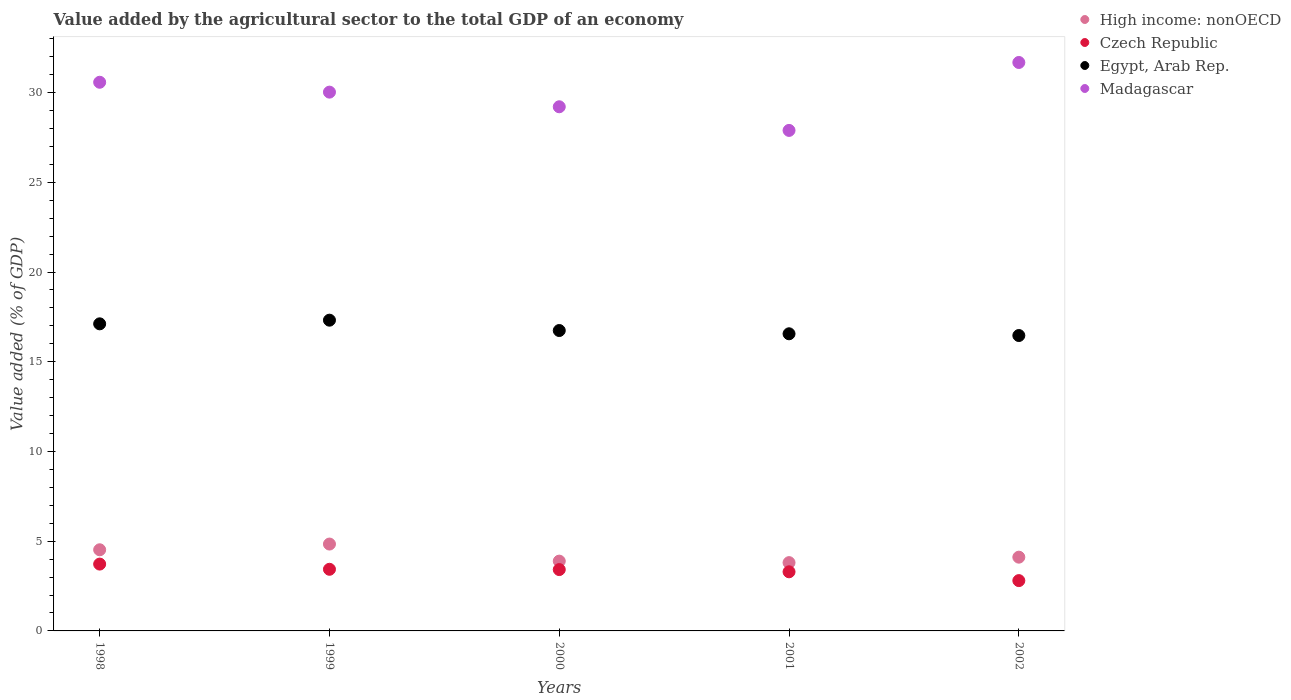What is the value added by the agricultural sector to the total GDP in High income: nonOECD in 2001?
Your answer should be compact. 3.81. Across all years, what is the maximum value added by the agricultural sector to the total GDP in Czech Republic?
Ensure brevity in your answer.  3.72. Across all years, what is the minimum value added by the agricultural sector to the total GDP in High income: nonOECD?
Ensure brevity in your answer.  3.81. In which year was the value added by the agricultural sector to the total GDP in High income: nonOECD maximum?
Keep it short and to the point. 1999. What is the total value added by the agricultural sector to the total GDP in Madagascar in the graph?
Make the answer very short. 149.38. What is the difference between the value added by the agricultural sector to the total GDP in High income: nonOECD in 1998 and that in 2002?
Your answer should be very brief. 0.41. What is the difference between the value added by the agricultural sector to the total GDP in Czech Republic in 2002 and the value added by the agricultural sector to the total GDP in High income: nonOECD in 2001?
Provide a succinct answer. -1. What is the average value added by the agricultural sector to the total GDP in High income: nonOECD per year?
Your response must be concise. 4.23. In the year 2002, what is the difference between the value added by the agricultural sector to the total GDP in Madagascar and value added by the agricultural sector to the total GDP in Egypt, Arab Rep.?
Ensure brevity in your answer.  15.22. What is the ratio of the value added by the agricultural sector to the total GDP in High income: nonOECD in 1999 to that in 2000?
Ensure brevity in your answer.  1.24. Is the value added by the agricultural sector to the total GDP in Czech Republic in 2001 less than that in 2002?
Ensure brevity in your answer.  No. Is the difference between the value added by the agricultural sector to the total GDP in Madagascar in 2000 and 2002 greater than the difference between the value added by the agricultural sector to the total GDP in Egypt, Arab Rep. in 2000 and 2002?
Give a very brief answer. No. What is the difference between the highest and the second highest value added by the agricultural sector to the total GDP in Egypt, Arab Rep.?
Your answer should be compact. 0.2. What is the difference between the highest and the lowest value added by the agricultural sector to the total GDP in Egypt, Arab Rep.?
Give a very brief answer. 0.86. Is the sum of the value added by the agricultural sector to the total GDP in High income: nonOECD in 1998 and 2000 greater than the maximum value added by the agricultural sector to the total GDP in Czech Republic across all years?
Ensure brevity in your answer.  Yes. Is it the case that in every year, the sum of the value added by the agricultural sector to the total GDP in Madagascar and value added by the agricultural sector to the total GDP in High income: nonOECD  is greater than the sum of value added by the agricultural sector to the total GDP in Czech Republic and value added by the agricultural sector to the total GDP in Egypt, Arab Rep.?
Your answer should be compact. No. Is it the case that in every year, the sum of the value added by the agricultural sector to the total GDP in Egypt, Arab Rep. and value added by the agricultural sector to the total GDP in Czech Republic  is greater than the value added by the agricultural sector to the total GDP in Madagascar?
Offer a terse response. No. Is the value added by the agricultural sector to the total GDP in High income: nonOECD strictly greater than the value added by the agricultural sector to the total GDP in Egypt, Arab Rep. over the years?
Your answer should be very brief. No. How many dotlines are there?
Offer a very short reply. 4. How many years are there in the graph?
Provide a succinct answer. 5. Are the values on the major ticks of Y-axis written in scientific E-notation?
Ensure brevity in your answer.  No. Does the graph contain any zero values?
Your answer should be very brief. No. Does the graph contain grids?
Give a very brief answer. No. How are the legend labels stacked?
Offer a terse response. Vertical. What is the title of the graph?
Your answer should be compact. Value added by the agricultural sector to the total GDP of an economy. Does "Jordan" appear as one of the legend labels in the graph?
Give a very brief answer. No. What is the label or title of the Y-axis?
Keep it short and to the point. Value added (% of GDP). What is the Value added (% of GDP) in High income: nonOECD in 1998?
Give a very brief answer. 4.52. What is the Value added (% of GDP) in Czech Republic in 1998?
Provide a short and direct response. 3.72. What is the Value added (% of GDP) of Egypt, Arab Rep. in 1998?
Your answer should be compact. 17.11. What is the Value added (% of GDP) of Madagascar in 1998?
Ensure brevity in your answer.  30.58. What is the Value added (% of GDP) of High income: nonOECD in 1999?
Ensure brevity in your answer.  4.84. What is the Value added (% of GDP) in Czech Republic in 1999?
Make the answer very short. 3.43. What is the Value added (% of GDP) of Egypt, Arab Rep. in 1999?
Provide a short and direct response. 17.32. What is the Value added (% of GDP) of Madagascar in 1999?
Your answer should be compact. 30.03. What is the Value added (% of GDP) in High income: nonOECD in 2000?
Your answer should be very brief. 3.89. What is the Value added (% of GDP) in Czech Republic in 2000?
Your answer should be very brief. 3.42. What is the Value added (% of GDP) of Egypt, Arab Rep. in 2000?
Provide a succinct answer. 16.74. What is the Value added (% of GDP) of Madagascar in 2000?
Keep it short and to the point. 29.21. What is the Value added (% of GDP) of High income: nonOECD in 2001?
Offer a very short reply. 3.81. What is the Value added (% of GDP) in Czech Republic in 2001?
Make the answer very short. 3.29. What is the Value added (% of GDP) of Egypt, Arab Rep. in 2001?
Your answer should be very brief. 16.56. What is the Value added (% of GDP) of Madagascar in 2001?
Make the answer very short. 27.89. What is the Value added (% of GDP) of High income: nonOECD in 2002?
Provide a succinct answer. 4.11. What is the Value added (% of GDP) of Czech Republic in 2002?
Give a very brief answer. 2.8. What is the Value added (% of GDP) in Egypt, Arab Rep. in 2002?
Your response must be concise. 16.46. What is the Value added (% of GDP) of Madagascar in 2002?
Your answer should be very brief. 31.68. Across all years, what is the maximum Value added (% of GDP) of High income: nonOECD?
Provide a short and direct response. 4.84. Across all years, what is the maximum Value added (% of GDP) of Czech Republic?
Give a very brief answer. 3.72. Across all years, what is the maximum Value added (% of GDP) in Egypt, Arab Rep.?
Give a very brief answer. 17.32. Across all years, what is the maximum Value added (% of GDP) of Madagascar?
Provide a succinct answer. 31.68. Across all years, what is the minimum Value added (% of GDP) of High income: nonOECD?
Your answer should be very brief. 3.81. Across all years, what is the minimum Value added (% of GDP) in Czech Republic?
Your response must be concise. 2.8. Across all years, what is the minimum Value added (% of GDP) of Egypt, Arab Rep.?
Make the answer very short. 16.46. Across all years, what is the minimum Value added (% of GDP) of Madagascar?
Your answer should be compact. 27.89. What is the total Value added (% of GDP) of High income: nonOECD in the graph?
Your answer should be compact. 21.17. What is the total Value added (% of GDP) of Czech Republic in the graph?
Ensure brevity in your answer.  16.68. What is the total Value added (% of GDP) in Egypt, Arab Rep. in the graph?
Provide a short and direct response. 84.19. What is the total Value added (% of GDP) in Madagascar in the graph?
Give a very brief answer. 149.38. What is the difference between the Value added (% of GDP) in High income: nonOECD in 1998 and that in 1999?
Your response must be concise. -0.32. What is the difference between the Value added (% of GDP) of Czech Republic in 1998 and that in 1999?
Keep it short and to the point. 0.29. What is the difference between the Value added (% of GDP) in Egypt, Arab Rep. in 1998 and that in 1999?
Offer a terse response. -0.2. What is the difference between the Value added (% of GDP) in Madagascar in 1998 and that in 1999?
Your answer should be very brief. 0.55. What is the difference between the Value added (% of GDP) of High income: nonOECD in 1998 and that in 2000?
Ensure brevity in your answer.  0.63. What is the difference between the Value added (% of GDP) of Czech Republic in 1998 and that in 2000?
Keep it short and to the point. 0.31. What is the difference between the Value added (% of GDP) in Egypt, Arab Rep. in 1998 and that in 2000?
Keep it short and to the point. 0.37. What is the difference between the Value added (% of GDP) of Madagascar in 1998 and that in 2000?
Offer a terse response. 1.37. What is the difference between the Value added (% of GDP) in High income: nonOECD in 1998 and that in 2001?
Your response must be concise. 0.72. What is the difference between the Value added (% of GDP) of Czech Republic in 1998 and that in 2001?
Keep it short and to the point. 0.43. What is the difference between the Value added (% of GDP) of Egypt, Arab Rep. in 1998 and that in 2001?
Offer a terse response. 0.56. What is the difference between the Value added (% of GDP) of Madagascar in 1998 and that in 2001?
Provide a succinct answer. 2.68. What is the difference between the Value added (% of GDP) of High income: nonOECD in 1998 and that in 2002?
Your response must be concise. 0.41. What is the difference between the Value added (% of GDP) of Czech Republic in 1998 and that in 2002?
Offer a very short reply. 0.92. What is the difference between the Value added (% of GDP) in Egypt, Arab Rep. in 1998 and that in 2002?
Give a very brief answer. 0.65. What is the difference between the Value added (% of GDP) of Madagascar in 1998 and that in 2002?
Make the answer very short. -1.1. What is the difference between the Value added (% of GDP) in High income: nonOECD in 1999 and that in 2000?
Offer a very short reply. 0.95. What is the difference between the Value added (% of GDP) in Czech Republic in 1999 and that in 2000?
Ensure brevity in your answer.  0.02. What is the difference between the Value added (% of GDP) in Egypt, Arab Rep. in 1999 and that in 2000?
Provide a short and direct response. 0.58. What is the difference between the Value added (% of GDP) of Madagascar in 1999 and that in 2000?
Keep it short and to the point. 0.82. What is the difference between the Value added (% of GDP) of High income: nonOECD in 1999 and that in 2001?
Offer a terse response. 1.04. What is the difference between the Value added (% of GDP) of Czech Republic in 1999 and that in 2001?
Your answer should be very brief. 0.14. What is the difference between the Value added (% of GDP) in Egypt, Arab Rep. in 1999 and that in 2001?
Keep it short and to the point. 0.76. What is the difference between the Value added (% of GDP) of Madagascar in 1999 and that in 2001?
Offer a terse response. 2.13. What is the difference between the Value added (% of GDP) of High income: nonOECD in 1999 and that in 2002?
Offer a terse response. 0.73. What is the difference between the Value added (% of GDP) of Czech Republic in 1999 and that in 2002?
Offer a terse response. 0.63. What is the difference between the Value added (% of GDP) of Egypt, Arab Rep. in 1999 and that in 2002?
Ensure brevity in your answer.  0.86. What is the difference between the Value added (% of GDP) of Madagascar in 1999 and that in 2002?
Give a very brief answer. -1.65. What is the difference between the Value added (% of GDP) in High income: nonOECD in 2000 and that in 2001?
Ensure brevity in your answer.  0.08. What is the difference between the Value added (% of GDP) of Czech Republic in 2000 and that in 2001?
Your response must be concise. 0.12. What is the difference between the Value added (% of GDP) in Egypt, Arab Rep. in 2000 and that in 2001?
Keep it short and to the point. 0.18. What is the difference between the Value added (% of GDP) in Madagascar in 2000 and that in 2001?
Give a very brief answer. 1.32. What is the difference between the Value added (% of GDP) in High income: nonOECD in 2000 and that in 2002?
Your answer should be compact. -0.22. What is the difference between the Value added (% of GDP) of Czech Republic in 2000 and that in 2002?
Give a very brief answer. 0.61. What is the difference between the Value added (% of GDP) of Egypt, Arab Rep. in 2000 and that in 2002?
Provide a short and direct response. 0.28. What is the difference between the Value added (% of GDP) in Madagascar in 2000 and that in 2002?
Make the answer very short. -2.47. What is the difference between the Value added (% of GDP) of High income: nonOECD in 2001 and that in 2002?
Provide a succinct answer. -0.3. What is the difference between the Value added (% of GDP) in Czech Republic in 2001 and that in 2002?
Offer a terse response. 0.49. What is the difference between the Value added (% of GDP) in Egypt, Arab Rep. in 2001 and that in 2002?
Offer a terse response. 0.1. What is the difference between the Value added (% of GDP) of Madagascar in 2001 and that in 2002?
Provide a short and direct response. -3.79. What is the difference between the Value added (% of GDP) in High income: nonOECD in 1998 and the Value added (% of GDP) in Czech Republic in 1999?
Your answer should be very brief. 1.09. What is the difference between the Value added (% of GDP) in High income: nonOECD in 1998 and the Value added (% of GDP) in Egypt, Arab Rep. in 1999?
Provide a succinct answer. -12.8. What is the difference between the Value added (% of GDP) in High income: nonOECD in 1998 and the Value added (% of GDP) in Madagascar in 1999?
Keep it short and to the point. -25.5. What is the difference between the Value added (% of GDP) of Czech Republic in 1998 and the Value added (% of GDP) of Egypt, Arab Rep. in 1999?
Your answer should be compact. -13.59. What is the difference between the Value added (% of GDP) in Czech Republic in 1998 and the Value added (% of GDP) in Madagascar in 1999?
Your answer should be compact. -26.3. What is the difference between the Value added (% of GDP) in Egypt, Arab Rep. in 1998 and the Value added (% of GDP) in Madagascar in 1999?
Make the answer very short. -12.91. What is the difference between the Value added (% of GDP) in High income: nonOECD in 1998 and the Value added (% of GDP) in Czech Republic in 2000?
Ensure brevity in your answer.  1.1. What is the difference between the Value added (% of GDP) of High income: nonOECD in 1998 and the Value added (% of GDP) of Egypt, Arab Rep. in 2000?
Ensure brevity in your answer.  -12.22. What is the difference between the Value added (% of GDP) of High income: nonOECD in 1998 and the Value added (% of GDP) of Madagascar in 2000?
Your response must be concise. -24.69. What is the difference between the Value added (% of GDP) of Czech Republic in 1998 and the Value added (% of GDP) of Egypt, Arab Rep. in 2000?
Your answer should be very brief. -13.02. What is the difference between the Value added (% of GDP) of Czech Republic in 1998 and the Value added (% of GDP) of Madagascar in 2000?
Offer a very short reply. -25.49. What is the difference between the Value added (% of GDP) in Egypt, Arab Rep. in 1998 and the Value added (% of GDP) in Madagascar in 2000?
Give a very brief answer. -12.1. What is the difference between the Value added (% of GDP) in High income: nonOECD in 1998 and the Value added (% of GDP) in Czech Republic in 2001?
Provide a succinct answer. 1.23. What is the difference between the Value added (% of GDP) of High income: nonOECD in 1998 and the Value added (% of GDP) of Egypt, Arab Rep. in 2001?
Your answer should be very brief. -12.04. What is the difference between the Value added (% of GDP) in High income: nonOECD in 1998 and the Value added (% of GDP) in Madagascar in 2001?
Provide a succinct answer. -23.37. What is the difference between the Value added (% of GDP) in Czech Republic in 1998 and the Value added (% of GDP) in Egypt, Arab Rep. in 2001?
Keep it short and to the point. -12.83. What is the difference between the Value added (% of GDP) of Czech Republic in 1998 and the Value added (% of GDP) of Madagascar in 2001?
Give a very brief answer. -24.17. What is the difference between the Value added (% of GDP) in Egypt, Arab Rep. in 1998 and the Value added (% of GDP) in Madagascar in 2001?
Your answer should be compact. -10.78. What is the difference between the Value added (% of GDP) in High income: nonOECD in 1998 and the Value added (% of GDP) in Czech Republic in 2002?
Ensure brevity in your answer.  1.72. What is the difference between the Value added (% of GDP) in High income: nonOECD in 1998 and the Value added (% of GDP) in Egypt, Arab Rep. in 2002?
Provide a short and direct response. -11.94. What is the difference between the Value added (% of GDP) of High income: nonOECD in 1998 and the Value added (% of GDP) of Madagascar in 2002?
Give a very brief answer. -27.16. What is the difference between the Value added (% of GDP) in Czech Republic in 1998 and the Value added (% of GDP) in Egypt, Arab Rep. in 2002?
Keep it short and to the point. -12.74. What is the difference between the Value added (% of GDP) in Czech Republic in 1998 and the Value added (% of GDP) in Madagascar in 2002?
Provide a succinct answer. -27.95. What is the difference between the Value added (% of GDP) of Egypt, Arab Rep. in 1998 and the Value added (% of GDP) of Madagascar in 2002?
Offer a terse response. -14.56. What is the difference between the Value added (% of GDP) in High income: nonOECD in 1999 and the Value added (% of GDP) in Czech Republic in 2000?
Ensure brevity in your answer.  1.42. What is the difference between the Value added (% of GDP) in High income: nonOECD in 1999 and the Value added (% of GDP) in Egypt, Arab Rep. in 2000?
Keep it short and to the point. -11.9. What is the difference between the Value added (% of GDP) in High income: nonOECD in 1999 and the Value added (% of GDP) in Madagascar in 2000?
Offer a very short reply. -24.37. What is the difference between the Value added (% of GDP) of Czech Republic in 1999 and the Value added (% of GDP) of Egypt, Arab Rep. in 2000?
Make the answer very short. -13.31. What is the difference between the Value added (% of GDP) in Czech Republic in 1999 and the Value added (% of GDP) in Madagascar in 2000?
Give a very brief answer. -25.78. What is the difference between the Value added (% of GDP) in Egypt, Arab Rep. in 1999 and the Value added (% of GDP) in Madagascar in 2000?
Make the answer very short. -11.89. What is the difference between the Value added (% of GDP) of High income: nonOECD in 1999 and the Value added (% of GDP) of Czech Republic in 2001?
Offer a very short reply. 1.55. What is the difference between the Value added (% of GDP) in High income: nonOECD in 1999 and the Value added (% of GDP) in Egypt, Arab Rep. in 2001?
Give a very brief answer. -11.72. What is the difference between the Value added (% of GDP) of High income: nonOECD in 1999 and the Value added (% of GDP) of Madagascar in 2001?
Give a very brief answer. -23.05. What is the difference between the Value added (% of GDP) in Czech Republic in 1999 and the Value added (% of GDP) in Egypt, Arab Rep. in 2001?
Your response must be concise. -13.12. What is the difference between the Value added (% of GDP) in Czech Republic in 1999 and the Value added (% of GDP) in Madagascar in 2001?
Ensure brevity in your answer.  -24.46. What is the difference between the Value added (% of GDP) of Egypt, Arab Rep. in 1999 and the Value added (% of GDP) of Madagascar in 2001?
Offer a very short reply. -10.58. What is the difference between the Value added (% of GDP) in High income: nonOECD in 1999 and the Value added (% of GDP) in Czech Republic in 2002?
Make the answer very short. 2.04. What is the difference between the Value added (% of GDP) of High income: nonOECD in 1999 and the Value added (% of GDP) of Egypt, Arab Rep. in 2002?
Your answer should be very brief. -11.62. What is the difference between the Value added (% of GDP) in High income: nonOECD in 1999 and the Value added (% of GDP) in Madagascar in 2002?
Give a very brief answer. -26.84. What is the difference between the Value added (% of GDP) of Czech Republic in 1999 and the Value added (% of GDP) of Egypt, Arab Rep. in 2002?
Keep it short and to the point. -13.03. What is the difference between the Value added (% of GDP) in Czech Republic in 1999 and the Value added (% of GDP) in Madagascar in 2002?
Your answer should be compact. -28.24. What is the difference between the Value added (% of GDP) of Egypt, Arab Rep. in 1999 and the Value added (% of GDP) of Madagascar in 2002?
Your answer should be very brief. -14.36. What is the difference between the Value added (% of GDP) in High income: nonOECD in 2000 and the Value added (% of GDP) in Czech Republic in 2001?
Give a very brief answer. 0.59. What is the difference between the Value added (% of GDP) in High income: nonOECD in 2000 and the Value added (% of GDP) in Egypt, Arab Rep. in 2001?
Ensure brevity in your answer.  -12.67. What is the difference between the Value added (% of GDP) in High income: nonOECD in 2000 and the Value added (% of GDP) in Madagascar in 2001?
Offer a very short reply. -24. What is the difference between the Value added (% of GDP) in Czech Republic in 2000 and the Value added (% of GDP) in Egypt, Arab Rep. in 2001?
Give a very brief answer. -13.14. What is the difference between the Value added (% of GDP) in Czech Republic in 2000 and the Value added (% of GDP) in Madagascar in 2001?
Ensure brevity in your answer.  -24.47. What is the difference between the Value added (% of GDP) in Egypt, Arab Rep. in 2000 and the Value added (% of GDP) in Madagascar in 2001?
Your response must be concise. -11.15. What is the difference between the Value added (% of GDP) of High income: nonOECD in 2000 and the Value added (% of GDP) of Czech Republic in 2002?
Ensure brevity in your answer.  1.09. What is the difference between the Value added (% of GDP) in High income: nonOECD in 2000 and the Value added (% of GDP) in Egypt, Arab Rep. in 2002?
Provide a short and direct response. -12.57. What is the difference between the Value added (% of GDP) of High income: nonOECD in 2000 and the Value added (% of GDP) of Madagascar in 2002?
Offer a terse response. -27.79. What is the difference between the Value added (% of GDP) of Czech Republic in 2000 and the Value added (% of GDP) of Egypt, Arab Rep. in 2002?
Your answer should be compact. -13.04. What is the difference between the Value added (% of GDP) of Czech Republic in 2000 and the Value added (% of GDP) of Madagascar in 2002?
Your answer should be very brief. -28.26. What is the difference between the Value added (% of GDP) in Egypt, Arab Rep. in 2000 and the Value added (% of GDP) in Madagascar in 2002?
Offer a terse response. -14.94. What is the difference between the Value added (% of GDP) in High income: nonOECD in 2001 and the Value added (% of GDP) in Egypt, Arab Rep. in 2002?
Keep it short and to the point. -12.66. What is the difference between the Value added (% of GDP) in High income: nonOECD in 2001 and the Value added (% of GDP) in Madagascar in 2002?
Offer a terse response. -27.87. What is the difference between the Value added (% of GDP) of Czech Republic in 2001 and the Value added (% of GDP) of Egypt, Arab Rep. in 2002?
Offer a terse response. -13.17. What is the difference between the Value added (% of GDP) of Czech Republic in 2001 and the Value added (% of GDP) of Madagascar in 2002?
Ensure brevity in your answer.  -28.38. What is the difference between the Value added (% of GDP) of Egypt, Arab Rep. in 2001 and the Value added (% of GDP) of Madagascar in 2002?
Give a very brief answer. -15.12. What is the average Value added (% of GDP) in High income: nonOECD per year?
Your answer should be compact. 4.23. What is the average Value added (% of GDP) of Czech Republic per year?
Offer a very short reply. 3.34. What is the average Value added (% of GDP) of Egypt, Arab Rep. per year?
Offer a terse response. 16.84. What is the average Value added (% of GDP) of Madagascar per year?
Ensure brevity in your answer.  29.88. In the year 1998, what is the difference between the Value added (% of GDP) in High income: nonOECD and Value added (% of GDP) in Czech Republic?
Keep it short and to the point. 0.8. In the year 1998, what is the difference between the Value added (% of GDP) in High income: nonOECD and Value added (% of GDP) in Egypt, Arab Rep.?
Offer a very short reply. -12.59. In the year 1998, what is the difference between the Value added (% of GDP) in High income: nonOECD and Value added (% of GDP) in Madagascar?
Offer a very short reply. -26.05. In the year 1998, what is the difference between the Value added (% of GDP) in Czech Republic and Value added (% of GDP) in Egypt, Arab Rep.?
Your answer should be very brief. -13.39. In the year 1998, what is the difference between the Value added (% of GDP) of Czech Republic and Value added (% of GDP) of Madagascar?
Your answer should be compact. -26.85. In the year 1998, what is the difference between the Value added (% of GDP) in Egypt, Arab Rep. and Value added (% of GDP) in Madagascar?
Ensure brevity in your answer.  -13.46. In the year 1999, what is the difference between the Value added (% of GDP) of High income: nonOECD and Value added (% of GDP) of Czech Republic?
Offer a very short reply. 1.41. In the year 1999, what is the difference between the Value added (% of GDP) in High income: nonOECD and Value added (% of GDP) in Egypt, Arab Rep.?
Your answer should be very brief. -12.48. In the year 1999, what is the difference between the Value added (% of GDP) of High income: nonOECD and Value added (% of GDP) of Madagascar?
Offer a very short reply. -25.18. In the year 1999, what is the difference between the Value added (% of GDP) in Czech Republic and Value added (% of GDP) in Egypt, Arab Rep.?
Make the answer very short. -13.88. In the year 1999, what is the difference between the Value added (% of GDP) of Czech Republic and Value added (% of GDP) of Madagascar?
Give a very brief answer. -26.59. In the year 1999, what is the difference between the Value added (% of GDP) of Egypt, Arab Rep. and Value added (% of GDP) of Madagascar?
Offer a terse response. -12.71. In the year 2000, what is the difference between the Value added (% of GDP) in High income: nonOECD and Value added (% of GDP) in Czech Republic?
Give a very brief answer. 0.47. In the year 2000, what is the difference between the Value added (% of GDP) of High income: nonOECD and Value added (% of GDP) of Egypt, Arab Rep.?
Keep it short and to the point. -12.85. In the year 2000, what is the difference between the Value added (% of GDP) in High income: nonOECD and Value added (% of GDP) in Madagascar?
Your answer should be compact. -25.32. In the year 2000, what is the difference between the Value added (% of GDP) of Czech Republic and Value added (% of GDP) of Egypt, Arab Rep.?
Ensure brevity in your answer.  -13.32. In the year 2000, what is the difference between the Value added (% of GDP) of Czech Republic and Value added (% of GDP) of Madagascar?
Your response must be concise. -25.79. In the year 2000, what is the difference between the Value added (% of GDP) of Egypt, Arab Rep. and Value added (% of GDP) of Madagascar?
Provide a short and direct response. -12.47. In the year 2001, what is the difference between the Value added (% of GDP) in High income: nonOECD and Value added (% of GDP) in Czech Republic?
Provide a succinct answer. 0.51. In the year 2001, what is the difference between the Value added (% of GDP) of High income: nonOECD and Value added (% of GDP) of Egypt, Arab Rep.?
Provide a short and direct response. -12.75. In the year 2001, what is the difference between the Value added (% of GDP) in High income: nonOECD and Value added (% of GDP) in Madagascar?
Provide a short and direct response. -24.09. In the year 2001, what is the difference between the Value added (% of GDP) of Czech Republic and Value added (% of GDP) of Egypt, Arab Rep.?
Make the answer very short. -13.26. In the year 2001, what is the difference between the Value added (% of GDP) in Czech Republic and Value added (% of GDP) in Madagascar?
Keep it short and to the point. -24.6. In the year 2001, what is the difference between the Value added (% of GDP) in Egypt, Arab Rep. and Value added (% of GDP) in Madagascar?
Your answer should be very brief. -11.33. In the year 2002, what is the difference between the Value added (% of GDP) in High income: nonOECD and Value added (% of GDP) in Czech Republic?
Offer a very short reply. 1.31. In the year 2002, what is the difference between the Value added (% of GDP) of High income: nonOECD and Value added (% of GDP) of Egypt, Arab Rep.?
Your answer should be very brief. -12.35. In the year 2002, what is the difference between the Value added (% of GDP) in High income: nonOECD and Value added (% of GDP) in Madagascar?
Offer a terse response. -27.57. In the year 2002, what is the difference between the Value added (% of GDP) in Czech Republic and Value added (% of GDP) in Egypt, Arab Rep.?
Make the answer very short. -13.66. In the year 2002, what is the difference between the Value added (% of GDP) of Czech Republic and Value added (% of GDP) of Madagascar?
Make the answer very short. -28.87. In the year 2002, what is the difference between the Value added (% of GDP) in Egypt, Arab Rep. and Value added (% of GDP) in Madagascar?
Make the answer very short. -15.22. What is the ratio of the Value added (% of GDP) in High income: nonOECD in 1998 to that in 1999?
Your answer should be compact. 0.93. What is the ratio of the Value added (% of GDP) in Czech Republic in 1998 to that in 1999?
Give a very brief answer. 1.08. What is the ratio of the Value added (% of GDP) of Egypt, Arab Rep. in 1998 to that in 1999?
Ensure brevity in your answer.  0.99. What is the ratio of the Value added (% of GDP) in Madagascar in 1998 to that in 1999?
Ensure brevity in your answer.  1.02. What is the ratio of the Value added (% of GDP) in High income: nonOECD in 1998 to that in 2000?
Provide a short and direct response. 1.16. What is the ratio of the Value added (% of GDP) of Czech Republic in 1998 to that in 2000?
Your answer should be very brief. 1.09. What is the ratio of the Value added (% of GDP) of Egypt, Arab Rep. in 1998 to that in 2000?
Your answer should be compact. 1.02. What is the ratio of the Value added (% of GDP) of Madagascar in 1998 to that in 2000?
Make the answer very short. 1.05. What is the ratio of the Value added (% of GDP) in High income: nonOECD in 1998 to that in 2001?
Keep it short and to the point. 1.19. What is the ratio of the Value added (% of GDP) of Czech Republic in 1998 to that in 2001?
Your response must be concise. 1.13. What is the ratio of the Value added (% of GDP) in Egypt, Arab Rep. in 1998 to that in 2001?
Provide a short and direct response. 1.03. What is the ratio of the Value added (% of GDP) in Madagascar in 1998 to that in 2001?
Offer a very short reply. 1.1. What is the ratio of the Value added (% of GDP) of High income: nonOECD in 1998 to that in 2002?
Provide a short and direct response. 1.1. What is the ratio of the Value added (% of GDP) in Czech Republic in 1998 to that in 2002?
Offer a terse response. 1.33. What is the ratio of the Value added (% of GDP) in Egypt, Arab Rep. in 1998 to that in 2002?
Keep it short and to the point. 1.04. What is the ratio of the Value added (% of GDP) of Madagascar in 1998 to that in 2002?
Offer a terse response. 0.97. What is the ratio of the Value added (% of GDP) of High income: nonOECD in 1999 to that in 2000?
Provide a succinct answer. 1.24. What is the ratio of the Value added (% of GDP) in Czech Republic in 1999 to that in 2000?
Ensure brevity in your answer.  1. What is the ratio of the Value added (% of GDP) in Egypt, Arab Rep. in 1999 to that in 2000?
Your answer should be compact. 1.03. What is the ratio of the Value added (% of GDP) in Madagascar in 1999 to that in 2000?
Offer a terse response. 1.03. What is the ratio of the Value added (% of GDP) of High income: nonOECD in 1999 to that in 2001?
Ensure brevity in your answer.  1.27. What is the ratio of the Value added (% of GDP) of Czech Republic in 1999 to that in 2001?
Offer a very short reply. 1.04. What is the ratio of the Value added (% of GDP) of Egypt, Arab Rep. in 1999 to that in 2001?
Your response must be concise. 1.05. What is the ratio of the Value added (% of GDP) in Madagascar in 1999 to that in 2001?
Offer a very short reply. 1.08. What is the ratio of the Value added (% of GDP) in High income: nonOECD in 1999 to that in 2002?
Keep it short and to the point. 1.18. What is the ratio of the Value added (% of GDP) in Czech Republic in 1999 to that in 2002?
Offer a terse response. 1.23. What is the ratio of the Value added (% of GDP) in Egypt, Arab Rep. in 1999 to that in 2002?
Offer a very short reply. 1.05. What is the ratio of the Value added (% of GDP) of Madagascar in 1999 to that in 2002?
Provide a short and direct response. 0.95. What is the ratio of the Value added (% of GDP) of High income: nonOECD in 2000 to that in 2001?
Provide a short and direct response. 1.02. What is the ratio of the Value added (% of GDP) in Czech Republic in 2000 to that in 2001?
Your response must be concise. 1.04. What is the ratio of the Value added (% of GDP) of Madagascar in 2000 to that in 2001?
Your response must be concise. 1.05. What is the ratio of the Value added (% of GDP) of High income: nonOECD in 2000 to that in 2002?
Your answer should be very brief. 0.95. What is the ratio of the Value added (% of GDP) of Czech Republic in 2000 to that in 2002?
Give a very brief answer. 1.22. What is the ratio of the Value added (% of GDP) of Egypt, Arab Rep. in 2000 to that in 2002?
Ensure brevity in your answer.  1.02. What is the ratio of the Value added (% of GDP) in Madagascar in 2000 to that in 2002?
Make the answer very short. 0.92. What is the ratio of the Value added (% of GDP) of High income: nonOECD in 2001 to that in 2002?
Provide a short and direct response. 0.93. What is the ratio of the Value added (% of GDP) in Czech Republic in 2001 to that in 2002?
Give a very brief answer. 1.18. What is the ratio of the Value added (% of GDP) in Egypt, Arab Rep. in 2001 to that in 2002?
Your response must be concise. 1.01. What is the ratio of the Value added (% of GDP) of Madagascar in 2001 to that in 2002?
Ensure brevity in your answer.  0.88. What is the difference between the highest and the second highest Value added (% of GDP) in High income: nonOECD?
Offer a terse response. 0.32. What is the difference between the highest and the second highest Value added (% of GDP) of Czech Republic?
Provide a succinct answer. 0.29. What is the difference between the highest and the second highest Value added (% of GDP) of Egypt, Arab Rep.?
Your response must be concise. 0.2. What is the difference between the highest and the second highest Value added (% of GDP) in Madagascar?
Your answer should be compact. 1.1. What is the difference between the highest and the lowest Value added (% of GDP) of High income: nonOECD?
Offer a terse response. 1.04. What is the difference between the highest and the lowest Value added (% of GDP) in Czech Republic?
Provide a succinct answer. 0.92. What is the difference between the highest and the lowest Value added (% of GDP) in Egypt, Arab Rep.?
Provide a short and direct response. 0.86. What is the difference between the highest and the lowest Value added (% of GDP) of Madagascar?
Your answer should be compact. 3.79. 